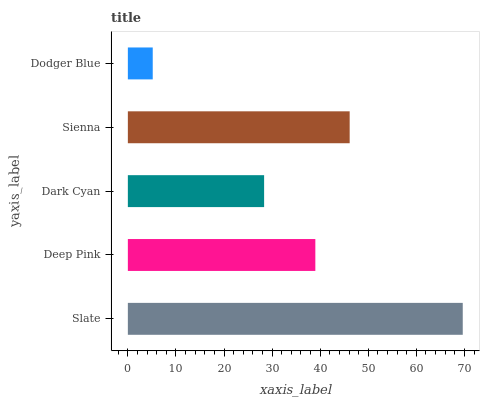Is Dodger Blue the minimum?
Answer yes or no. Yes. Is Slate the maximum?
Answer yes or no. Yes. Is Deep Pink the minimum?
Answer yes or no. No. Is Deep Pink the maximum?
Answer yes or no. No. Is Slate greater than Deep Pink?
Answer yes or no. Yes. Is Deep Pink less than Slate?
Answer yes or no. Yes. Is Deep Pink greater than Slate?
Answer yes or no. No. Is Slate less than Deep Pink?
Answer yes or no. No. Is Deep Pink the high median?
Answer yes or no. Yes. Is Deep Pink the low median?
Answer yes or no. Yes. Is Sienna the high median?
Answer yes or no. No. Is Sienna the low median?
Answer yes or no. No. 